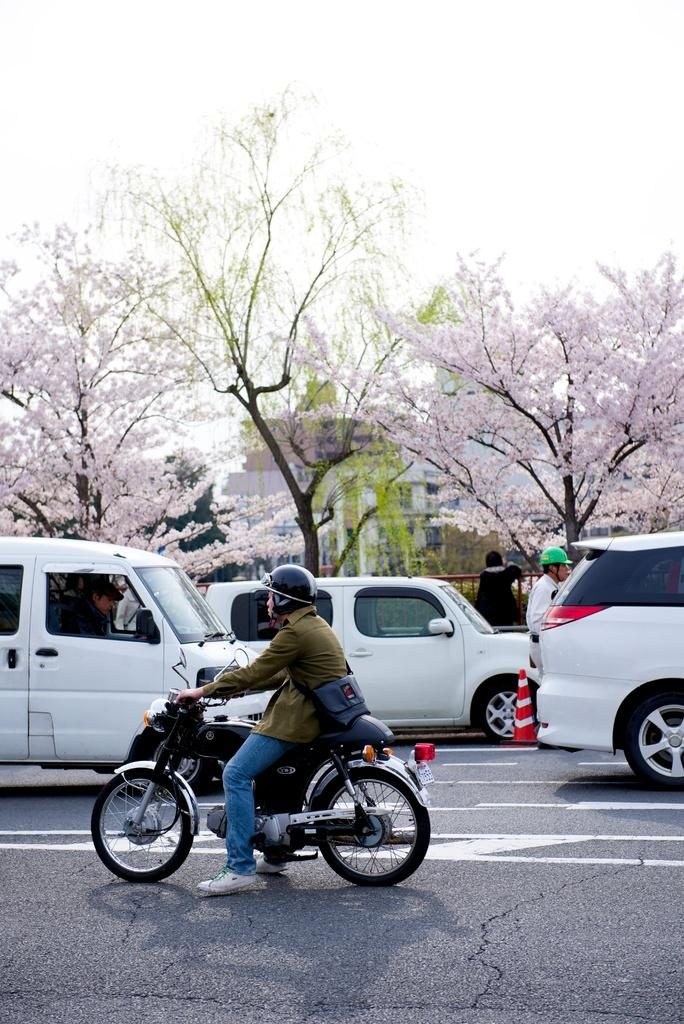What is the person in the image doing? There is a person riding a bicycle on the road in the image. How many cars are on the road in the image? There are three cars on the road in the image. What can be seen in the background of the image? There are trees and the sky visible in the background of the image. What color is the person's tongue in the image? There is no information about the person's tongue in the image, as the focus is on the person riding a bicycle and the surrounding environment. 